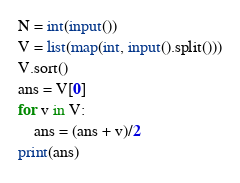<code> <loc_0><loc_0><loc_500><loc_500><_Python_>N = int(input())
V = list(map(int, input().split()))
V.sort()
ans = V[0]
for v in V:
	ans = (ans + v)/2
print(ans)</code> 